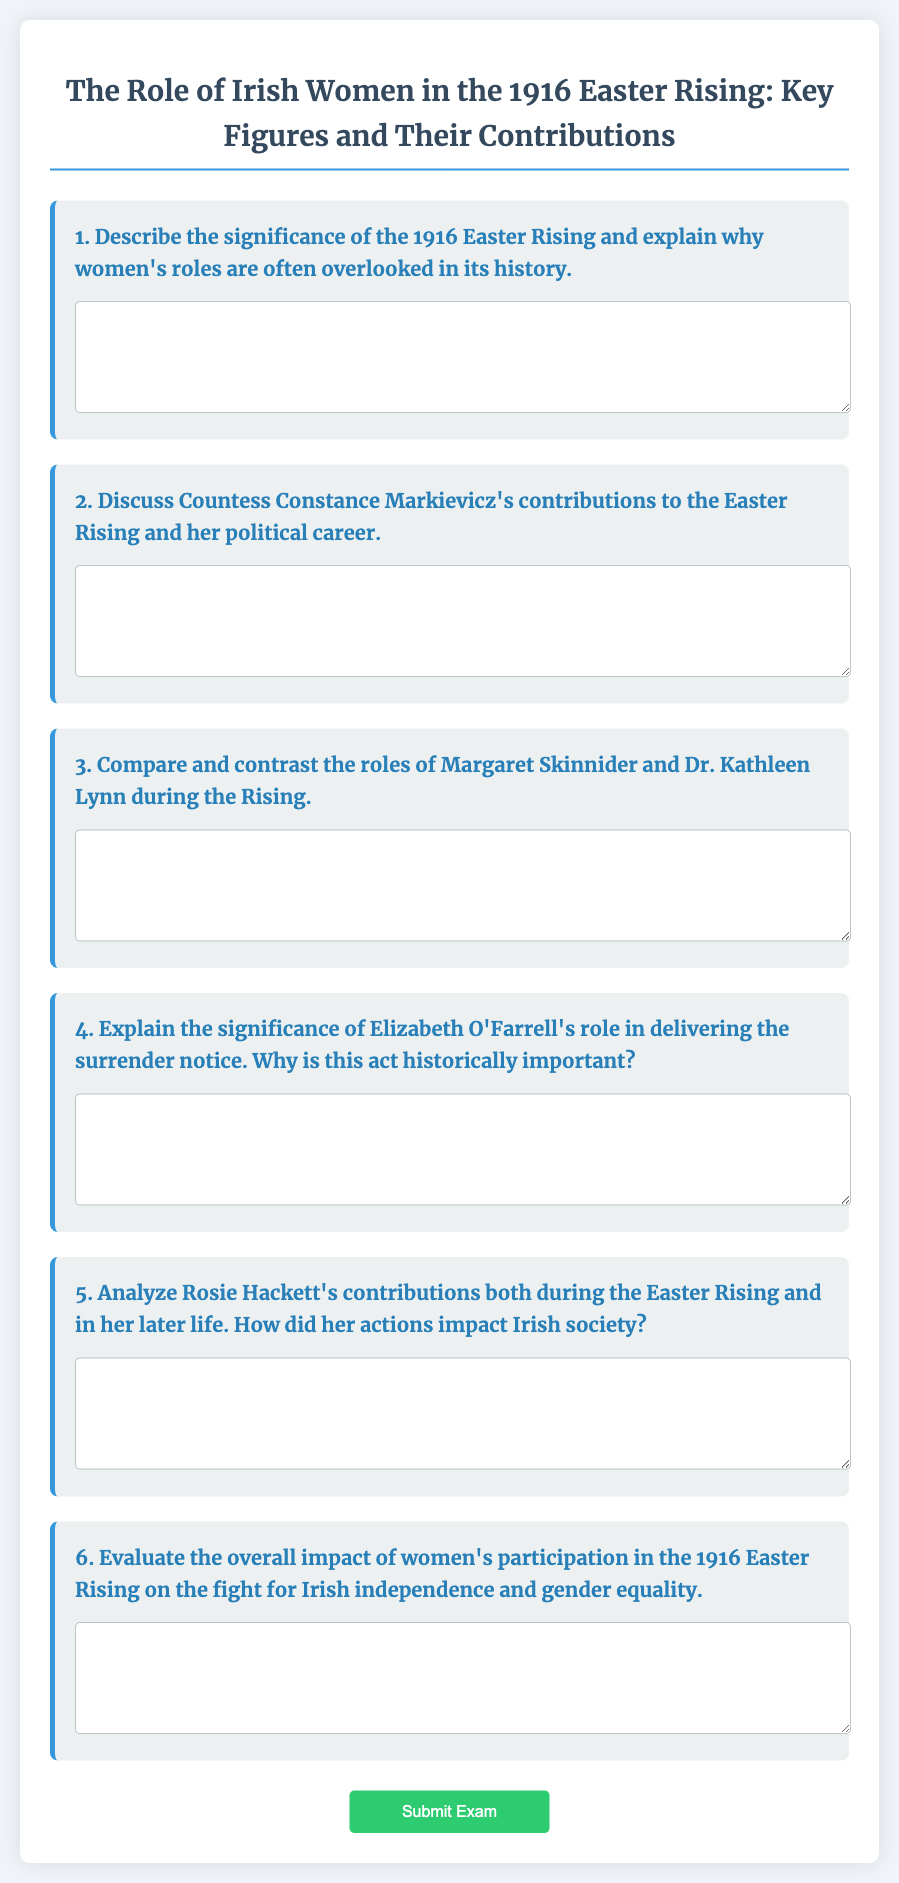What is the main focus of the exam? The exam focuses on the role of Irish women in the 1916 Easter Rising, specifically key figures and their contributions.
Answer: Role of Irish women in the 1916 Easter Rising How many questions are in the exam? The exam contains a total of six questions regarding key figures and their roles in the Easter Rising.
Answer: Six questions Who is the key figure associated with the description in question 2? Question 2 discusses Countess Constance Markievicz and her contributions during and after the Easter Rising.
Answer: Countess Constance Markievicz What specific action is highlighted in question 4? Question 4 highlights Elizabeth O'Farrell's role in delivering the surrender notice during the Easter Rising.
Answer: Delivering the surrender notice What is the title of question 6? Question 6 is titled "Evaluate the overall impact of women's participation in the 1916 Easter Rising on the fight for Irish independence and gender equality."
Answer: Evaluate the overall impact of women's participation in the 1916 Easter Rising on the fight for Irish independence and gender equality What unique element does this document contain? This document contains a structured exam format with short-answer questions regarding women's roles in the 1916 Easter Rising.
Answer: Exam format with short-answer questions 